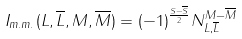Convert formula to latex. <formula><loc_0><loc_0><loc_500><loc_500>I _ { m . m . } ( L , \overline { L } , M , \overline { M } ) = ( - 1 ) ^ { \frac { S - \overline { S } } { 2 } } N ^ { M - \overline { M } } _ { L , \overline { L } }</formula> 